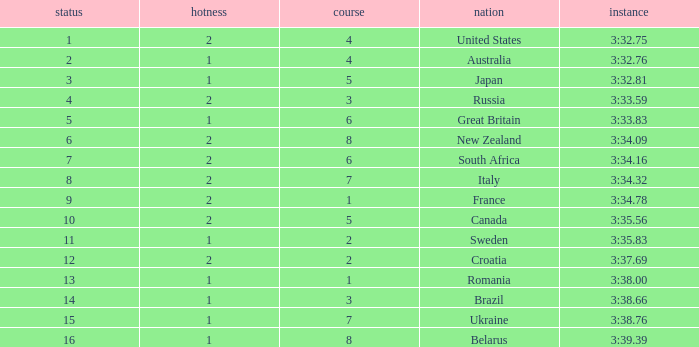Can you tell me the Rank that has the Lane of 6, and the Heat of 2? 7.0. 